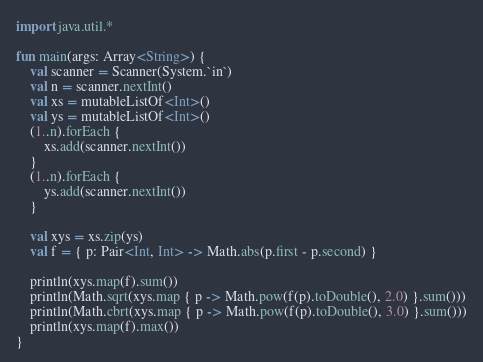Convert code to text. <code><loc_0><loc_0><loc_500><loc_500><_Kotlin_>import java.util.*

fun main(args: Array<String>) {
    val scanner = Scanner(System.`in`)
    val n = scanner.nextInt()
    val xs = mutableListOf<Int>()
    val ys = mutableListOf<Int>()
    (1..n).forEach {
        xs.add(scanner.nextInt())
    }
    (1..n).forEach {
        ys.add(scanner.nextInt())
    }

    val xys = xs.zip(ys)
    val f = { p: Pair<Int, Int> -> Math.abs(p.first - p.second) }

    println(xys.map(f).sum())
    println(Math.sqrt(xys.map { p -> Math.pow(f(p).toDouble(), 2.0) }.sum()))
    println(Math.cbrt(xys.map { p -> Math.pow(f(p).toDouble(), 3.0) }.sum()))
    println(xys.map(f).max())
}

</code> 